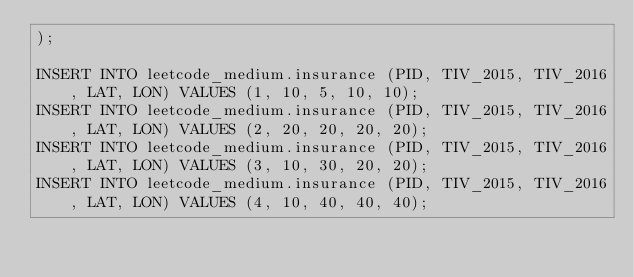<code> <loc_0><loc_0><loc_500><loc_500><_SQL_>);

INSERT INTO leetcode_medium.insurance (PID, TIV_2015, TIV_2016, LAT, LON) VALUES (1, 10, 5, 10, 10);
INSERT INTO leetcode_medium.insurance (PID, TIV_2015, TIV_2016, LAT, LON) VALUES (2, 20, 20, 20, 20);
INSERT INTO leetcode_medium.insurance (PID, TIV_2015, TIV_2016, LAT, LON) VALUES (3, 10, 30, 20, 20);
INSERT INTO leetcode_medium.insurance (PID, TIV_2015, TIV_2016, LAT, LON) VALUES (4, 10, 40, 40, 40);</code> 